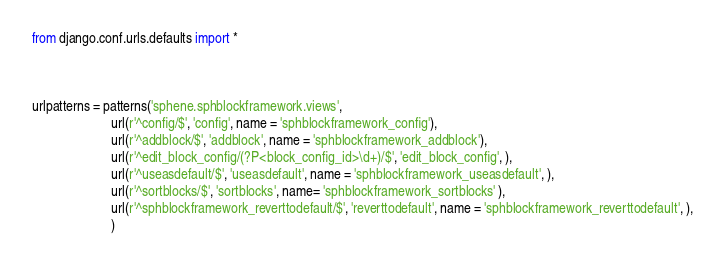<code> <loc_0><loc_0><loc_500><loc_500><_Python_>from django.conf.urls.defaults import *



urlpatterns = patterns('sphene.sphblockframework.views',
                       url(r'^config/$', 'config', name = 'sphblockframework_config'),
                       url(r'^addblock/$', 'addblock', name = 'sphblockframework_addblock'),
                       url(r'^edit_block_config/(?P<block_config_id>\d+)/$', 'edit_block_config', ),
                       url(r'^useasdefault/$', 'useasdefault', name = 'sphblockframework_useasdefault', ),
                       url(r'^sortblocks/$', 'sortblocks', name= 'sphblockframework_sortblocks' ),
                       url(r'^sphblockframework_reverttodefault/$', 'reverttodefault', name = 'sphblockframework_reverttodefault', ),
                       )


</code> 